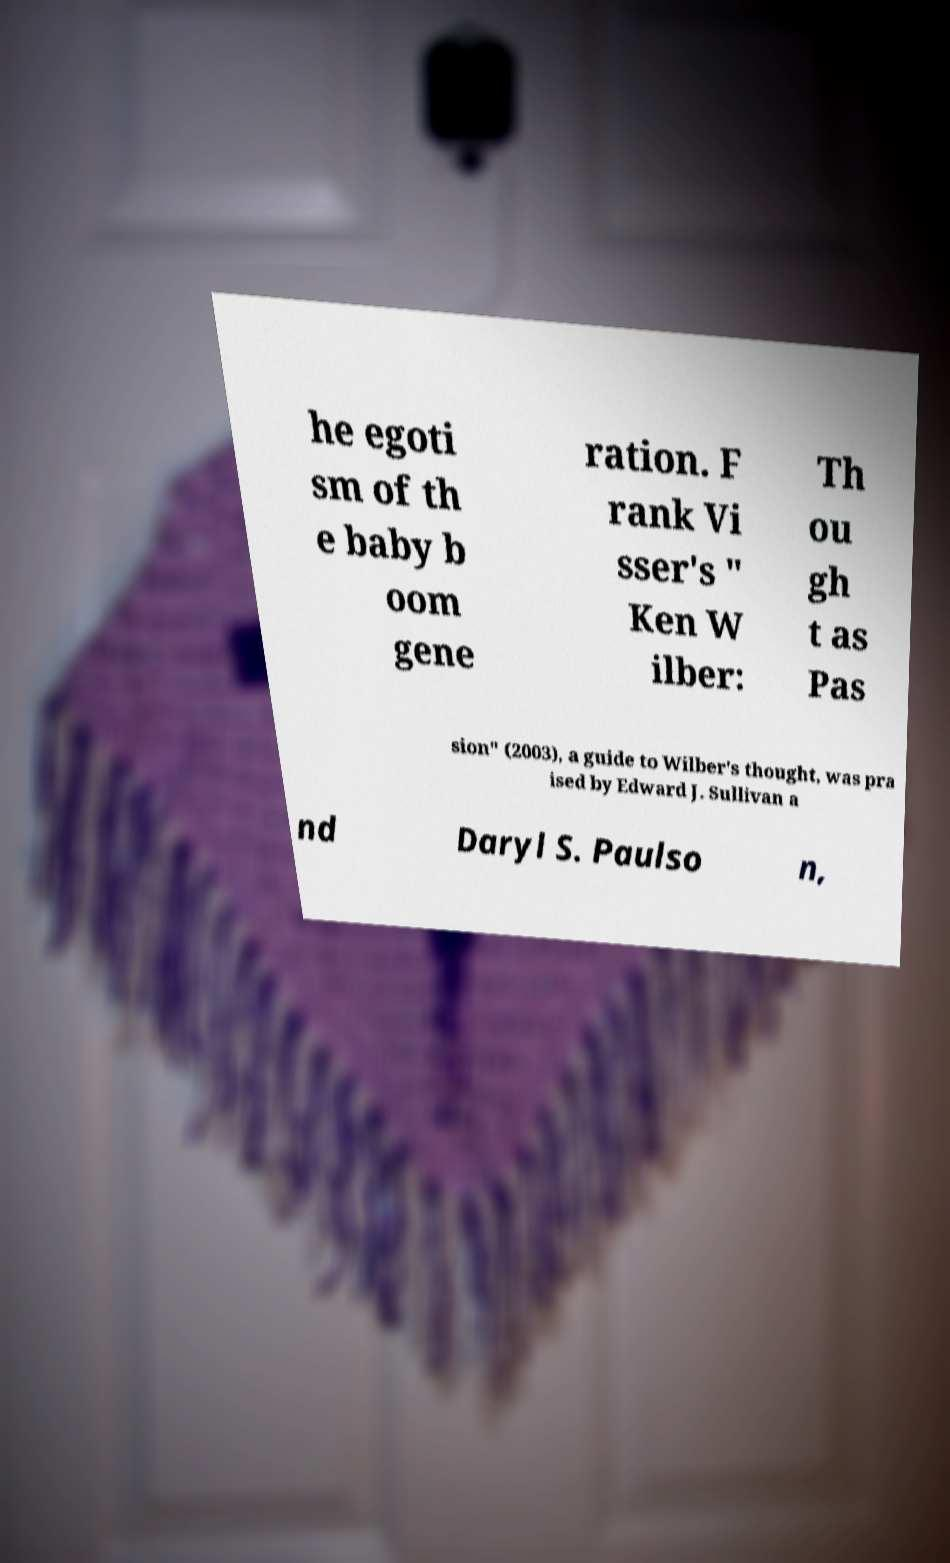Please read and relay the text visible in this image. What does it say? he egoti sm of th e baby b oom gene ration. F rank Vi sser's " Ken W ilber: Th ou gh t as Pas sion" (2003), a guide to Wilber's thought, was pra ised by Edward J. Sullivan a nd Daryl S. Paulso n, 